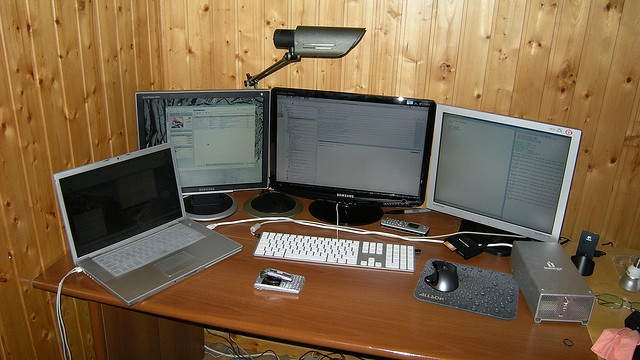Describe the objects in this image and their specific colors. I can see tv in tan, gray, and black tones, laptop in tan, black, gray, and darkgray tones, tv in tan, gray, darkgray, lightgray, and black tones, tv in olive, gray, and black tones, and keyboard in tan, lightgray, gray, and darkgray tones in this image. 